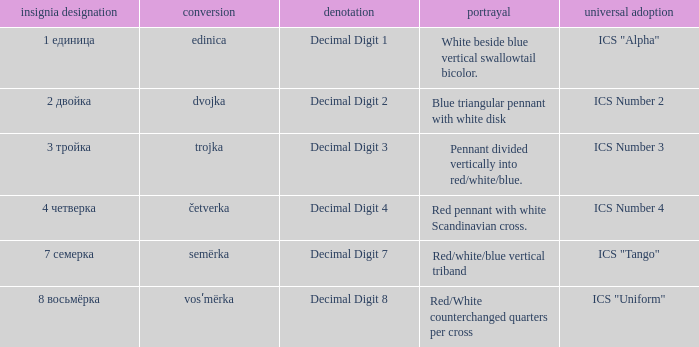What is the international use of the 1 единица flag? ICS "Alpha". 